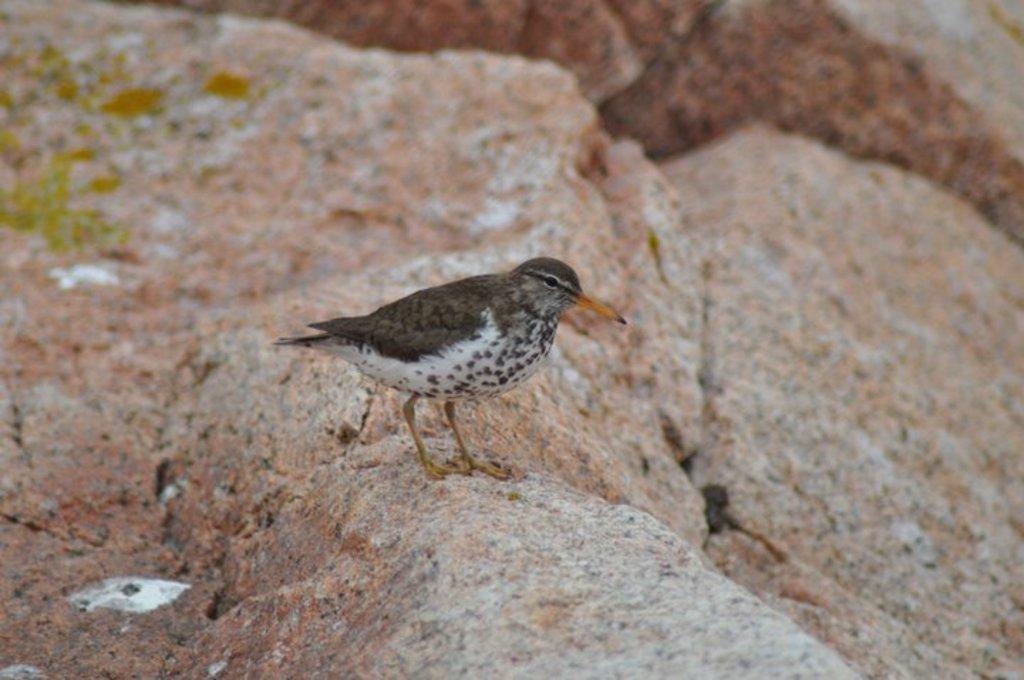Describe this image in one or two sentences. In this picture we can see a bird standing on a rock and in the background we can see rocks. 